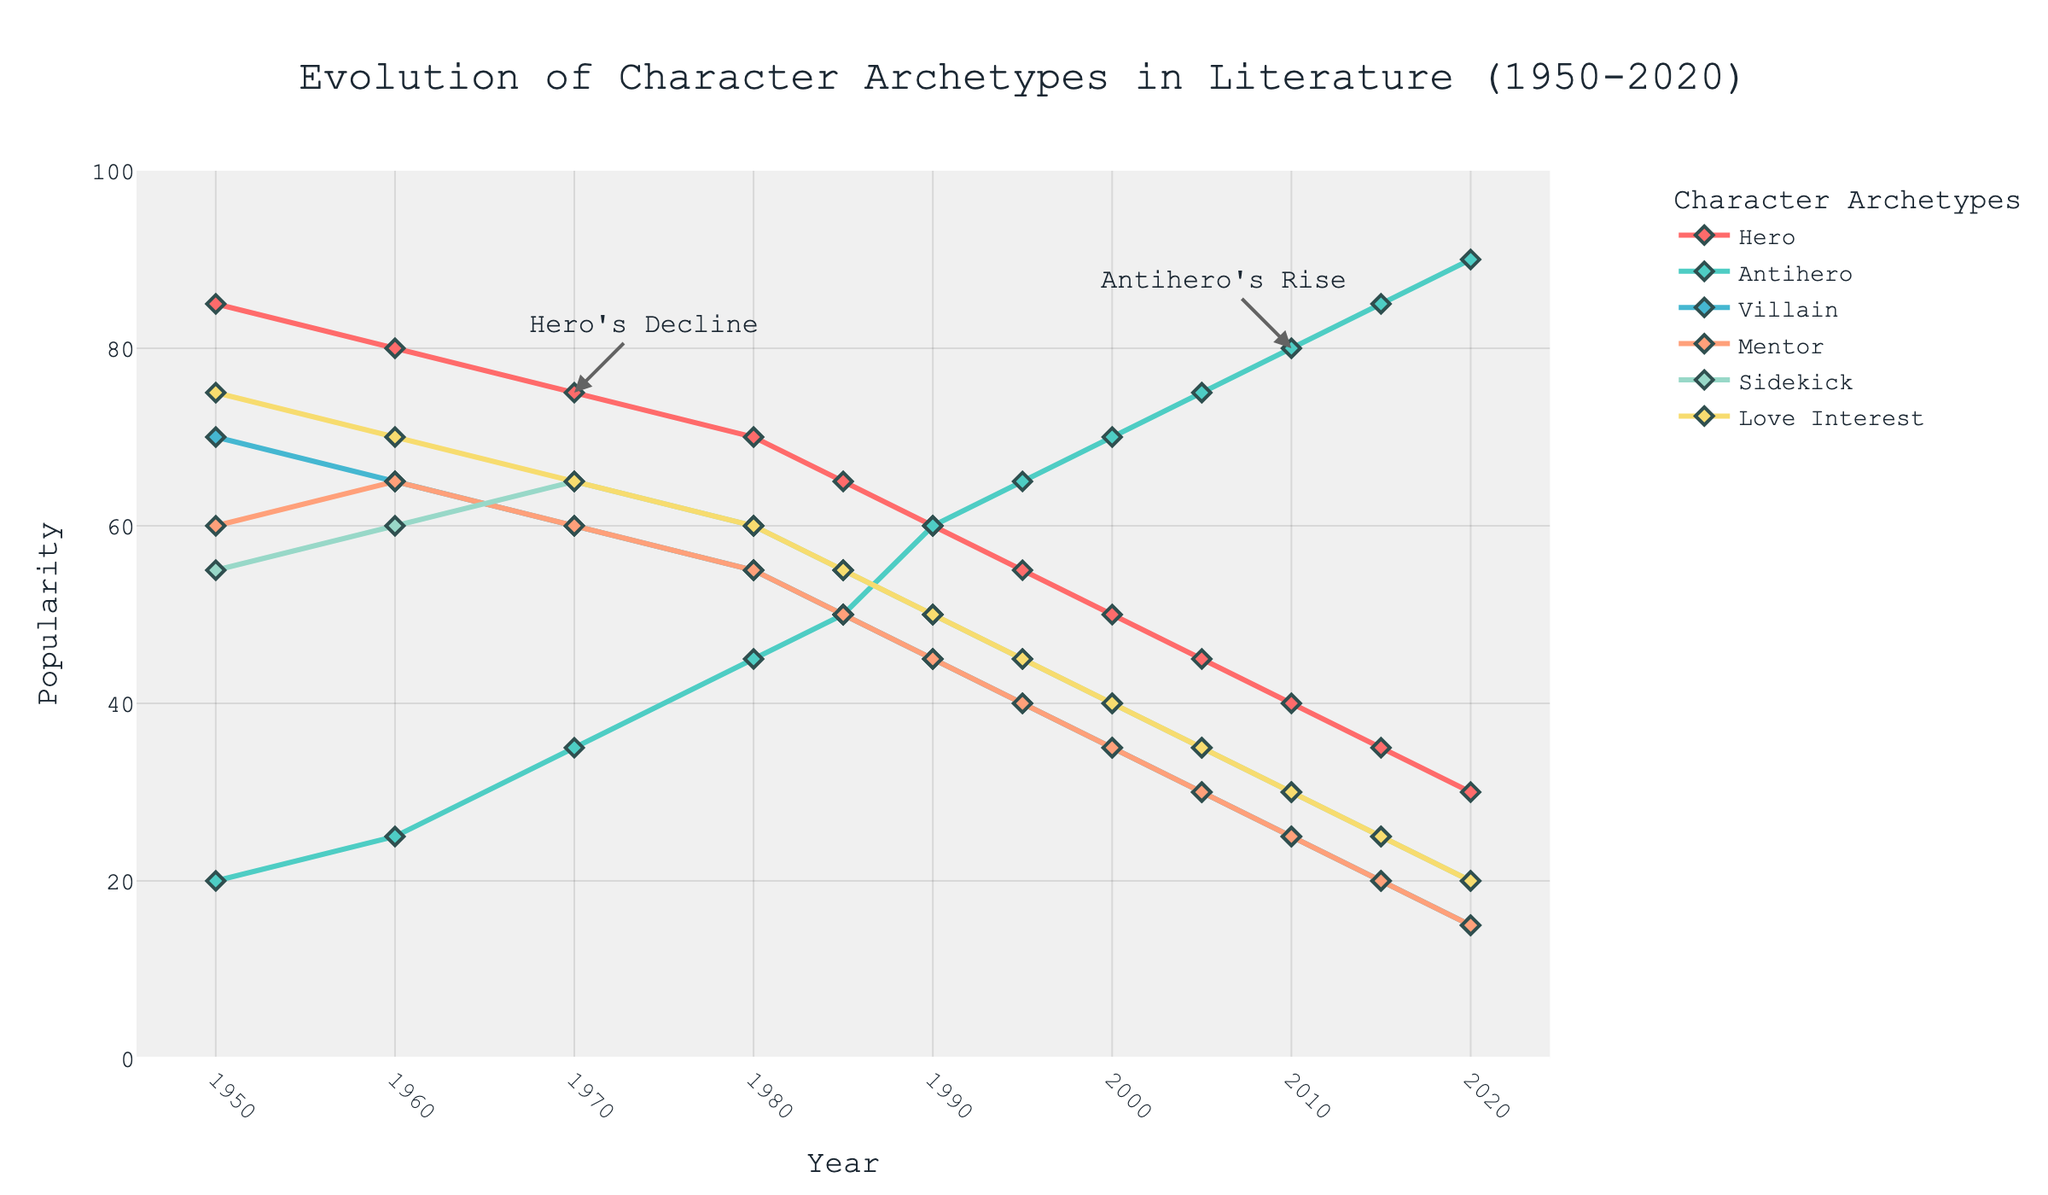What's the trend in the popularity of the Hero archetype from 1950 to 2020? The line chart shows the Hero archetype starting at 85 in 1950 and steadily declining each decade to 30 by 2020.
Answer: Steady decline Which character archetype had the highest popularity in 2020, and which had the lowest? The line chart shows that in 2020, the Antihero archetype had the highest popularity at 90, while the Villain had the lowest at 15.
Answer: Antihero highest, Villain lowest How much did the popularity of the Antihero archetype increase from 1950 to 2020? The line chart illustrates the Antihero archetype rising from 20 in 1950 to 90 in 2020. The increase is 90 - 20 = 70.
Answer: 70 Compare the popularity of the Mentor archetype between 1970 and 2005. In 1970, the popularity of the Mentor was 60. By 2005, it had decreased to 30. The difference is 60 - 30 = 30.
Answer: 30 decrease What year did the popularity of the Sidekick archetype surpass that of the Villain? By looking at the intersection of the Sidekick and Villain lines on the chart, we see the Sidekick surpasses the Villain around 1990.
Answer: Around 1990 Which two archetypes are annotated in the figure, and what do these annotations signify? The figure has annotations for the Antihero and Hero archetypes. The Antihero annotation ("Antihero's Rise") at 2010 signifies its increasing popularity, while the Hero annotation ("Hero's Decline") at 1970 highlights its declining trend.
Answer: Antihero's rise, Hero's decline What is the difference in popularity between the Love Interest and Mentor archetypes in 1985? The chart reveals that in 1985, the Love Interest has a popularity of 55, and the Mentor has 50. The difference is 55 - 50 = 5.
Answer: 5 How did the popularity of the Villain archetype change from 1980 to 2010? The Villain archetype popularity decreased from 55 in 1980 to 25 in 2010. The change is 55 - 25 = 30.
Answer: 30 decrease 